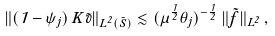<formula> <loc_0><loc_0><loc_500><loc_500>\| ( 1 - \psi _ { j } ) \, K \tilde { v } \| _ { L ^ { 2 } ( \tilde { S } ) } \lesssim ( \mu ^ { \frac { 1 } { 2 } } \theta _ { j } ) ^ { - \frac { 1 } { 2 } } \, \| \tilde { f } \| _ { L ^ { 2 } } \, ,</formula> 